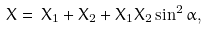Convert formula to latex. <formula><loc_0><loc_0><loc_500><loc_500>X = \, X _ { 1 } + X _ { 2 } + X _ { 1 } X _ { 2 } \sin ^ { 2 } \alpha ,</formula> 